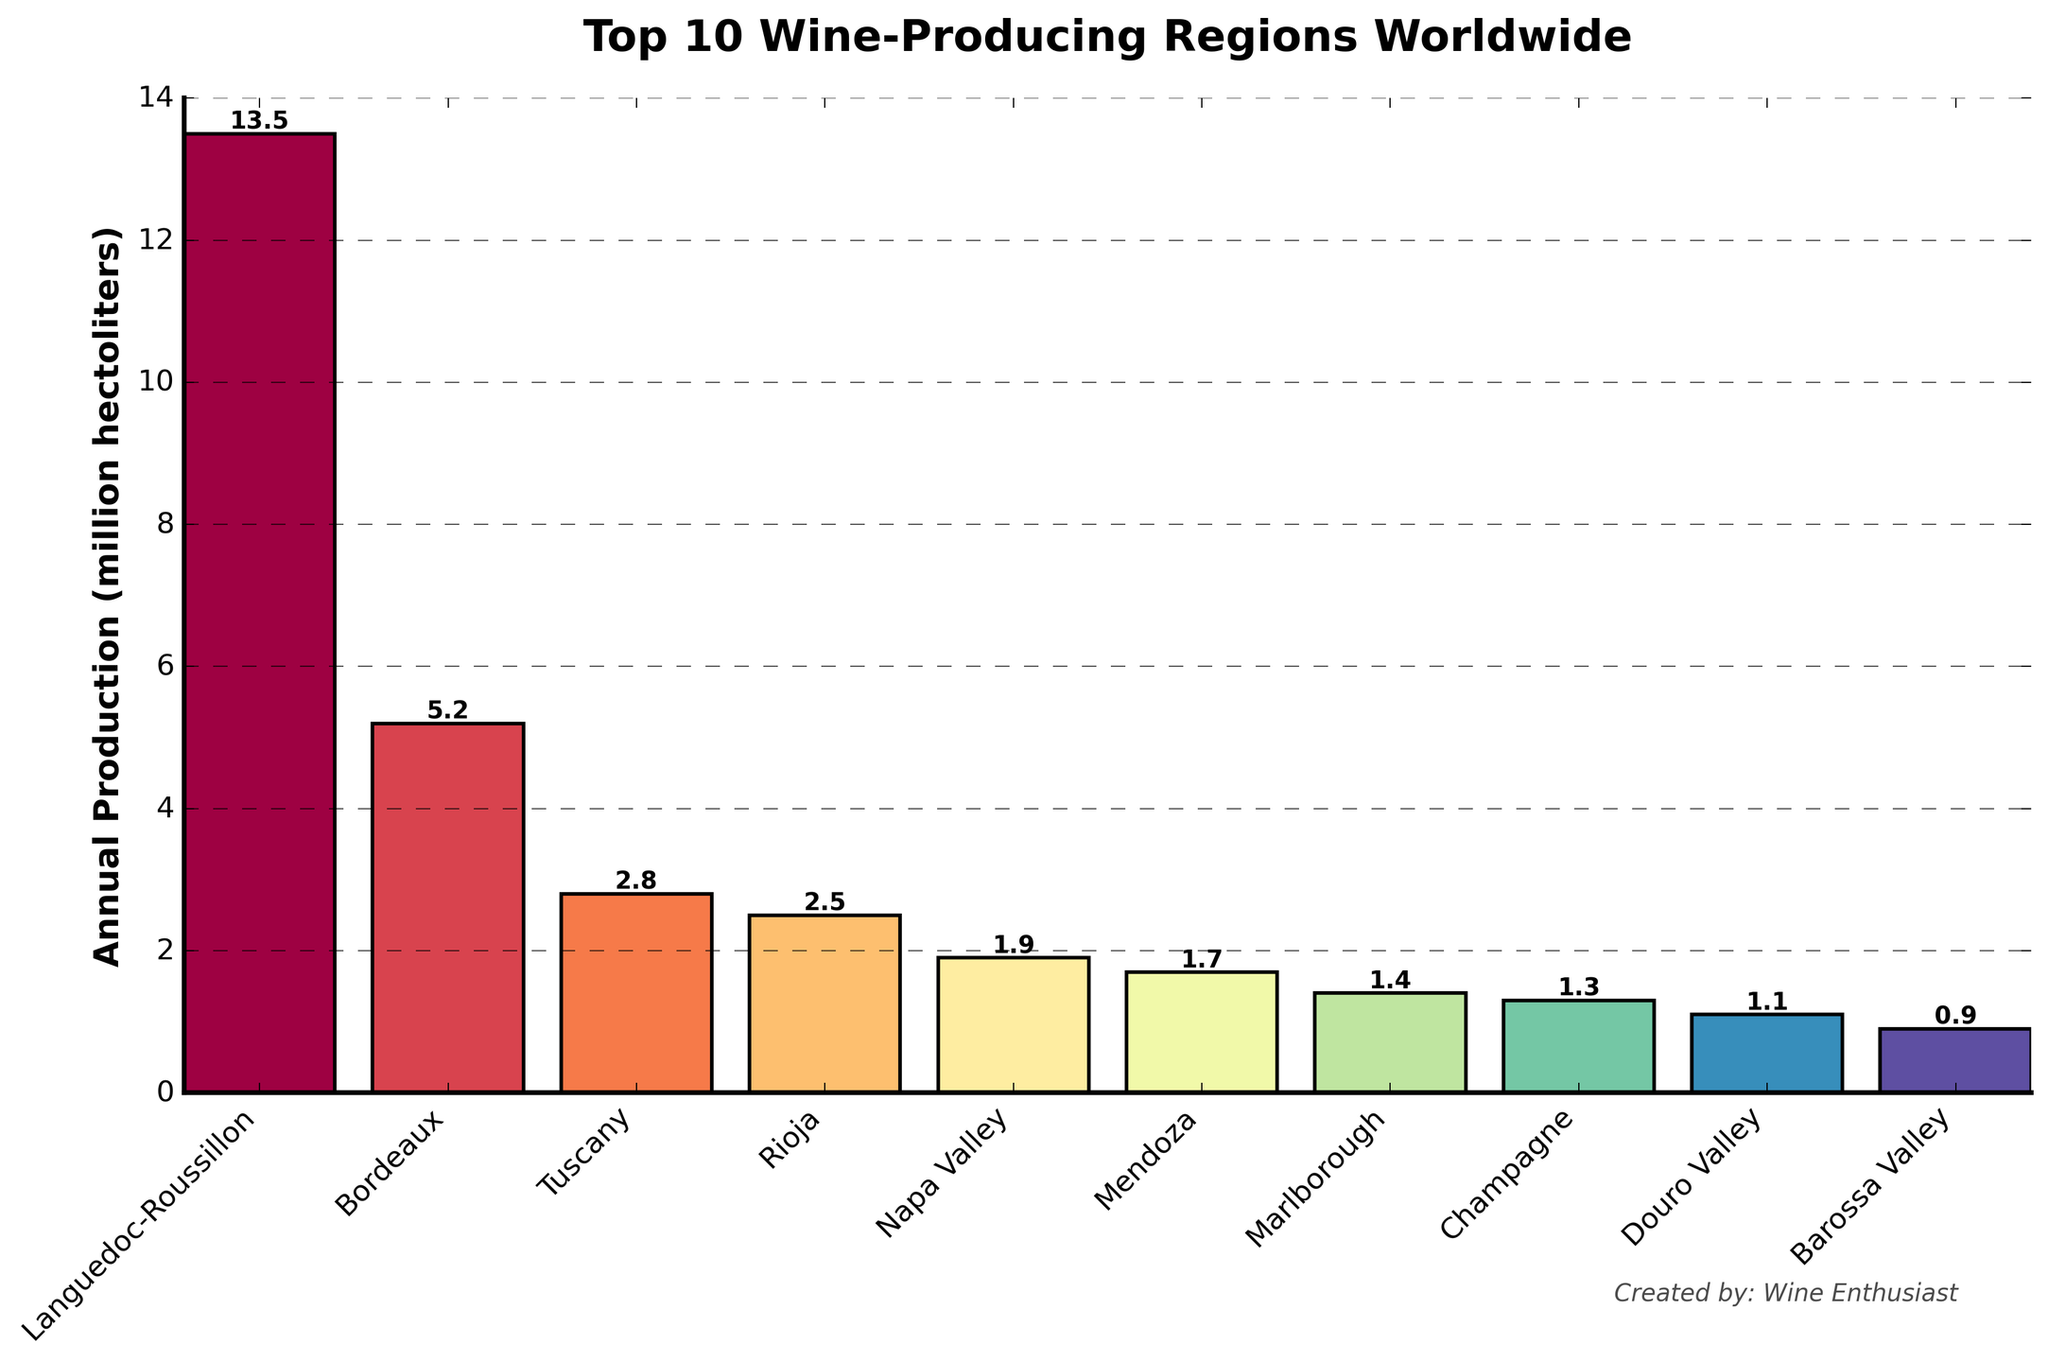Which region has the highest annual wine production? By observing the heights of the bars, we can see that the bar representing Languedoc-Roussillon is the tallest, indicating it has the highest annual wine production.
Answer: Languedoc-Roussillon How much more wine does Languedoc-Roussillon produce compared to Bordeaux? Languedoc-Roussillon's production is 13.5 million hectoliters and Bordeaux's is 5.2 million hectoliters. The difference is 13.5 - 5.2 = 8.3 million hectoliters.
Answer: 8.3 million hectoliters Which region produces the least amount of wine annually? By identifying the shortest bar, we notice that Barossa Valley has the shortest bar, indicating it produces the least amount of wine annually.
Answer: Barossa Valley What's the average annual wine production of the top 5 wine-producing regions? The top 5 regions are Languedoc-Roussillon (13.5), Bordeaux (5.2), Tuscany (2.8), Rioja (2.5), and Napa Valley (1.9). Adding their productions: 13.5 + 5.2 + 2.8 + 2.5 + 1.9 = 25.9 million hectoliters. The average is 25.9 / 5 = 5.18 million hectoliters.
Answer: 5.18 million hectoliters How many regions produce less than 2 million hectoliters of wine annually? By looking at the bars with heights less than 2, we see that Napa Valley, Mendoza, Marlborough, Champagne, Douro Valley, and Barossa Valley fall into this category, totaling 6 regions.
Answer: 6 regions What's the combined wine production of Mendoza and Marlborough? Adding the production of Mendoza (1.7 million hectoliters) and Marlborough (1.4 million hectoliters) gives 1.7 + 1.4 = 3.1 million hectoliters.
Answer: 3.1 million hectoliters Which two regions have the closest annual wine production volumes? By examining the heights of the bars, it appears Rioja (2.5 million hectoliters) and Tuscany (2.8 million hectoliters) have the closest production volumes, with a difference of 2.8 - 2.5 = 0.3 million hectoliters.
Answer: Rioja and Tuscany What is the total wine production of regions producing more than 3 million hectoliters annually? The regions producing more than 3 million hectoliters are Languedoc-Roussillon (13.5) and Bordeaux (5.2). Adding these gives 13.5 + 5.2 = 18.7 million hectoliters.
Answer: 18.7 million hectoliters What is the difference in wine production between the highest and the lowest producing regions? The highest producing region is Languedoc-Roussillon (13.5) and the lowest is Barossa Valley (0.9). The difference is 13.5 - 0.9 = 12.6 million hectoliters.
Answer: 12.6 million hectoliters 